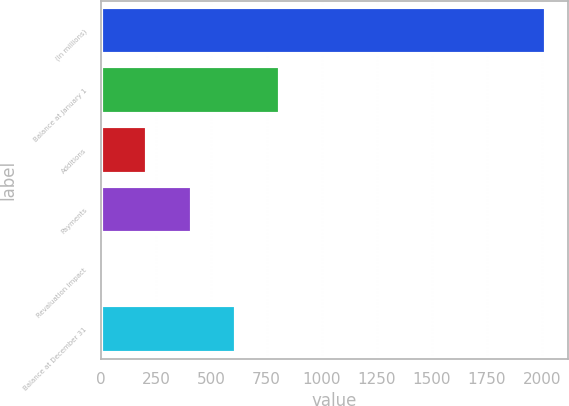Convert chart. <chart><loc_0><loc_0><loc_500><loc_500><bar_chart><fcel>(In millions)<fcel>Balance at January 1<fcel>Additions<fcel>Payments<fcel>Revaluation Impact<fcel>Balance at December 31<nl><fcel>2016<fcel>811.8<fcel>209.7<fcel>410.4<fcel>9<fcel>611.1<nl></chart> 